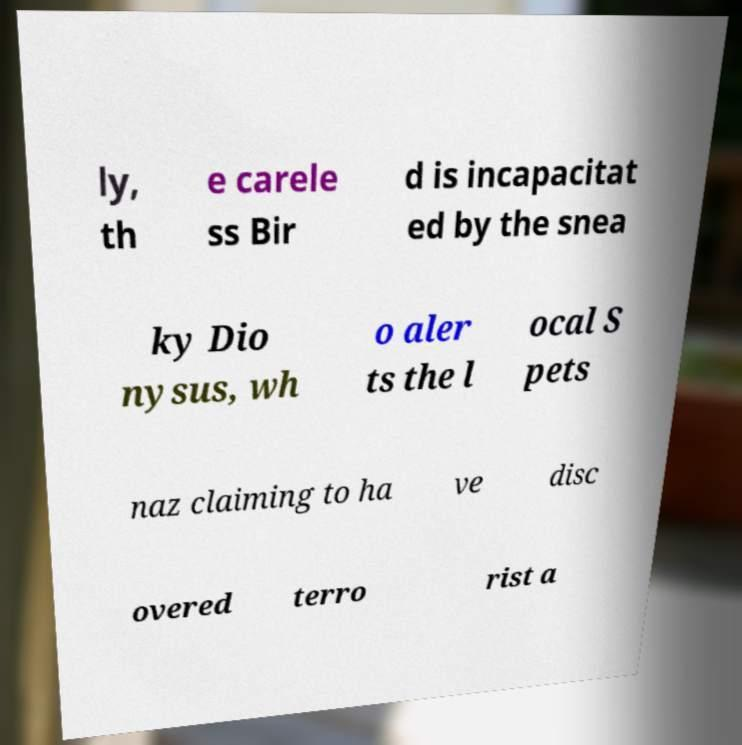Please identify and transcribe the text found in this image. ly, th e carele ss Bir d is incapacitat ed by the snea ky Dio nysus, wh o aler ts the l ocal S pets naz claiming to ha ve disc overed terro rist a 